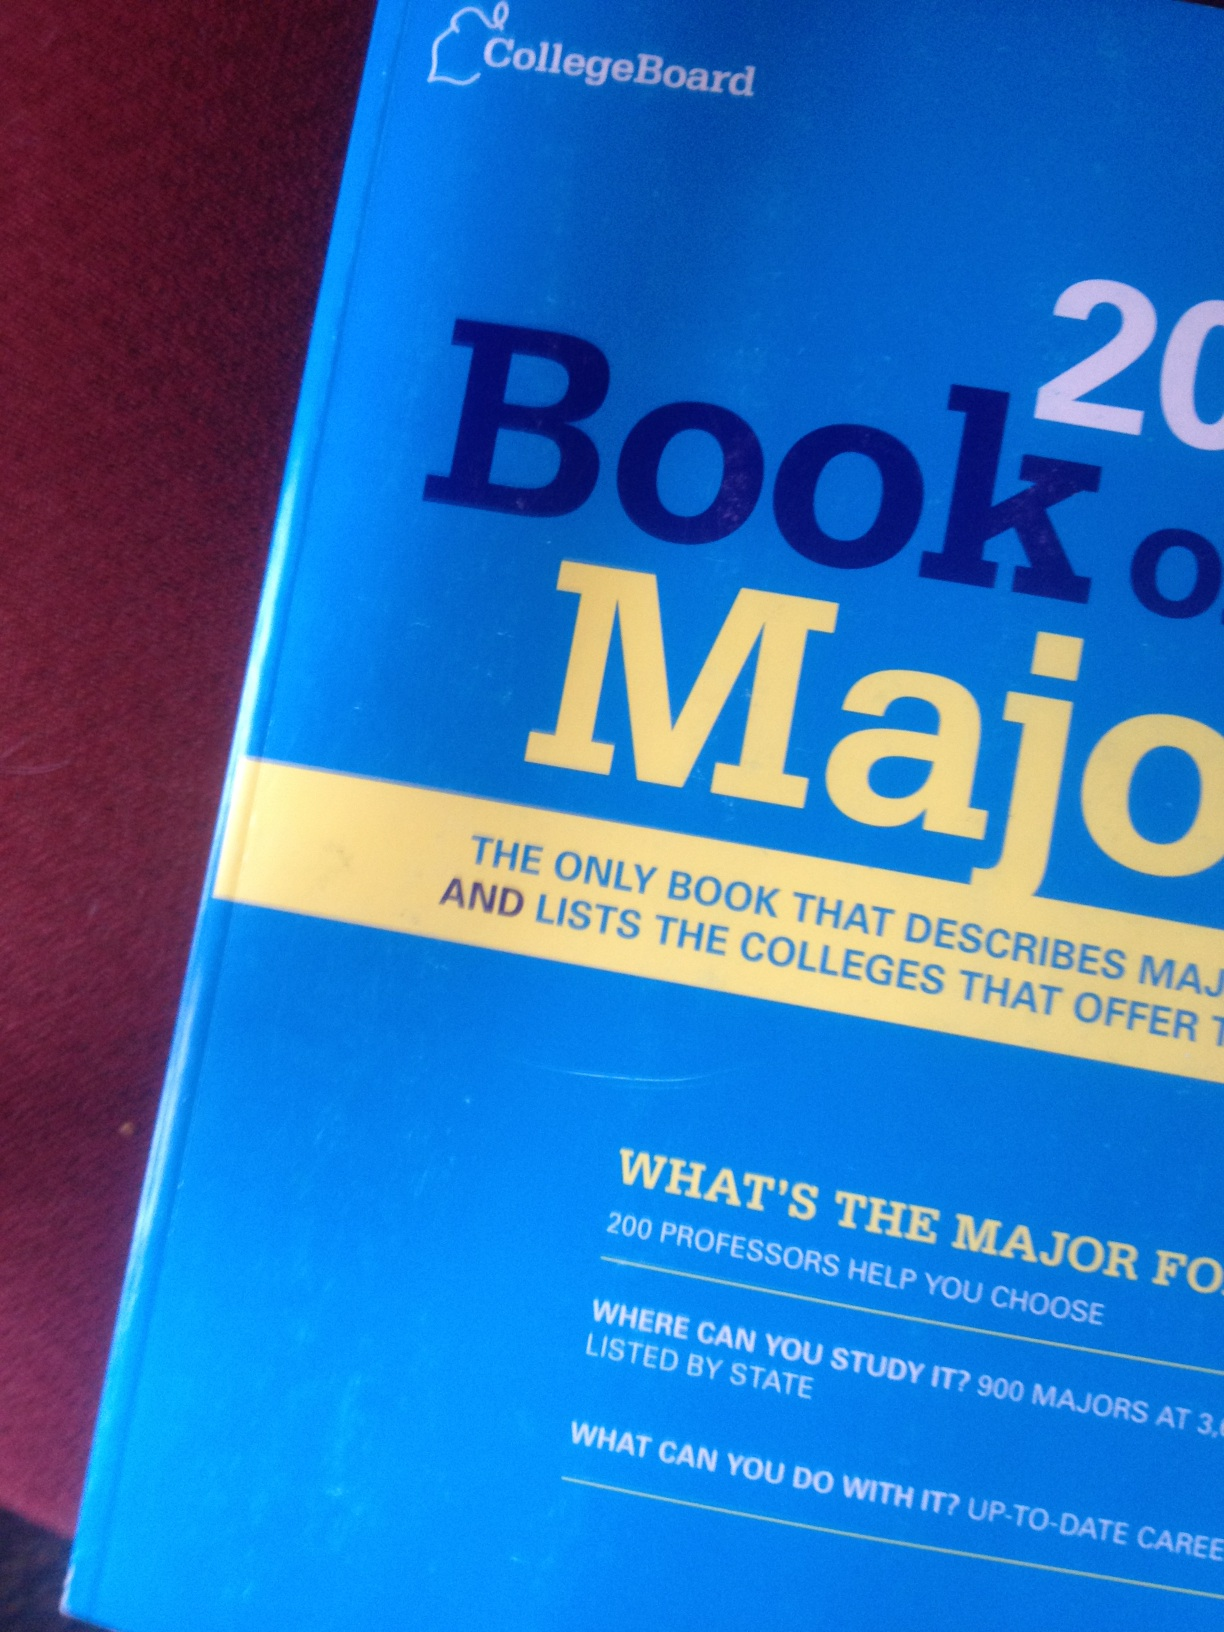What book is this? What is the title of this book? The book shown in the image is titled 'Book of Majors 2014'. This guide, published by CollegeBoard, provides a comprehensive description of various academic majors and lists the colleges that offer specific programs. It includes insights from 200 professors, details on where you can study 900 different majors, and information on potential career paths in the respective fields. 